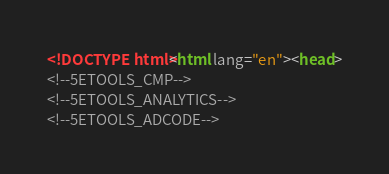Convert code to text. <code><loc_0><loc_0><loc_500><loc_500><_HTML_><!DOCTYPE html><html lang="en"><head>
<!--5ETOOLS_CMP-->
<!--5ETOOLS_ANALYTICS-->
<!--5ETOOLS_ADCODE--></code> 